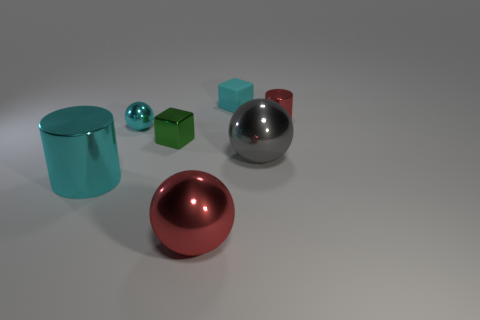Add 1 large metal cylinders. How many objects exist? 8 Subtract all cylinders. How many objects are left? 5 Subtract all large cyan metal cylinders. Subtract all large gray metal things. How many objects are left? 5 Add 1 red metallic cylinders. How many red metallic cylinders are left? 2 Add 1 gray spheres. How many gray spheres exist? 2 Subtract 0 gray cylinders. How many objects are left? 7 